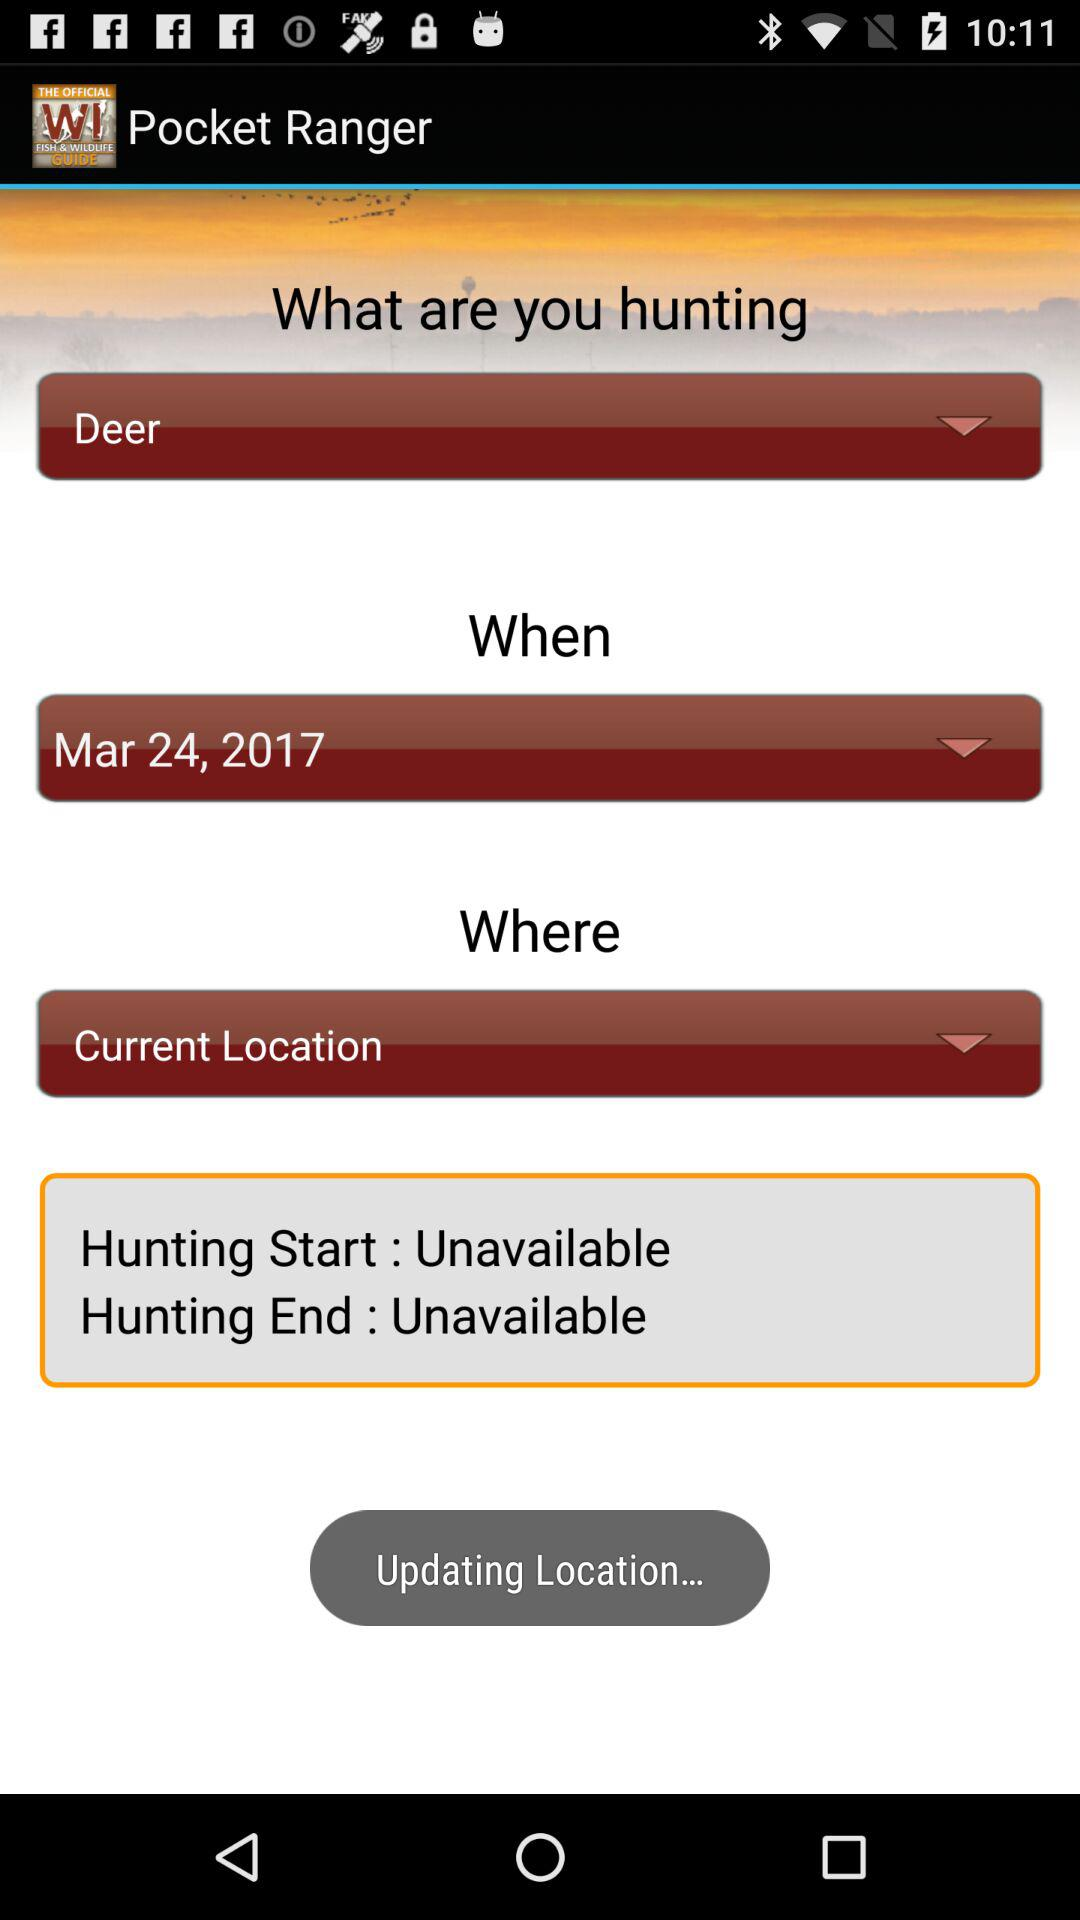What animal is selected for hunting? The selected animal is a deer. 